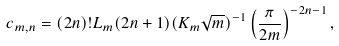<formula> <loc_0><loc_0><loc_500><loc_500>c _ { m , n } = ( 2 n ) ! L _ { m } ( 2 n + 1 ) ( K _ { m } \sqrt { m } ) ^ { - 1 } \left ( \frac { \pi } { 2 m } \right ) ^ { - 2 n - 1 } ,</formula> 